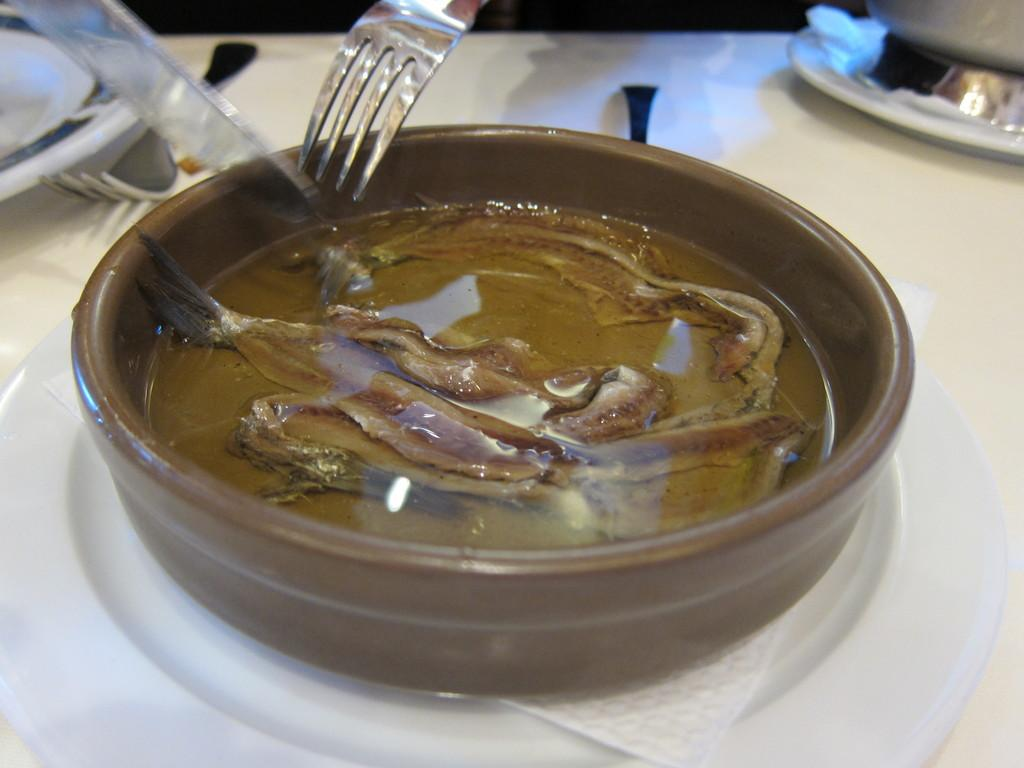What is in the bowl that is visible in the image? There is a bowl with fish in the image. What is the bowl placed on? The bowl is on a white color plate. Are there any other plates visible in the image? Yes, there are additional plates visible in the image. What utensils can be seen in the image? There are forks visible in the image. What is the color of the surface in the image? The white color surface is present in the image. What is the hourly profit generated by the fish in the image? There is no information about profit in the image, as it features a bowl of fish and related items. 